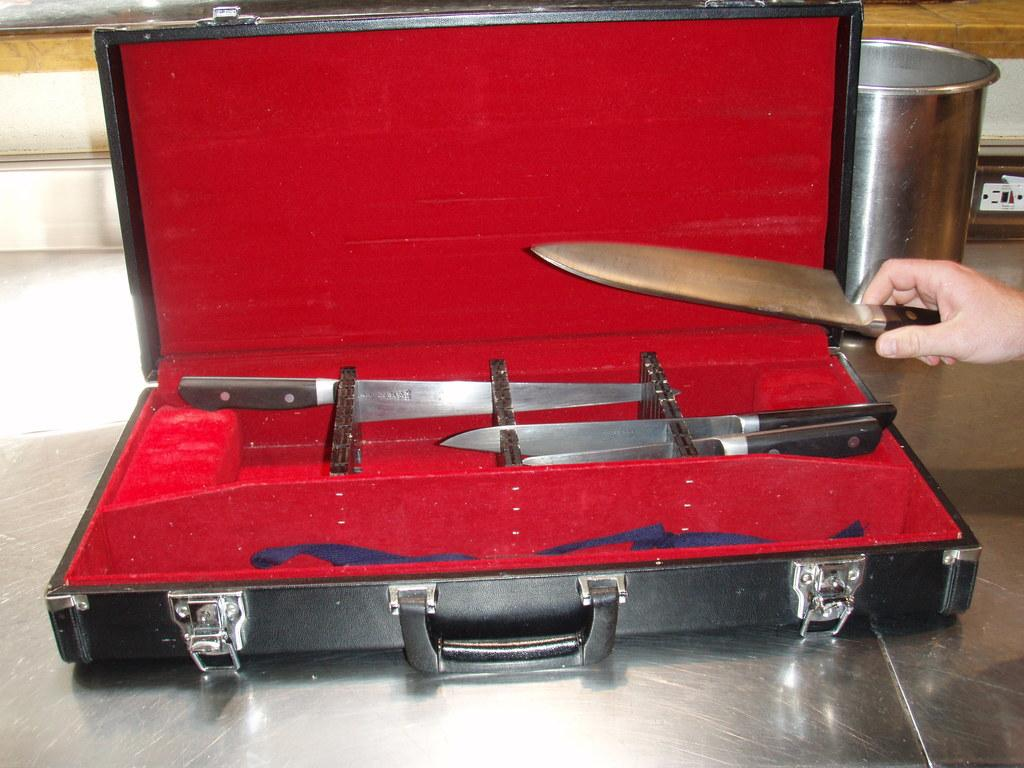What object can be seen in the image that people might use for traveling? There is a suitcase in the image that people might use for traveling. What is placed on top of the suitcase? There is a knife and a red cloth on the suitcase. What can be seen in the background of the image? There is a glass and a hand in the background of the image. What type of sticks can be seen leaning against the wall in the image? There is no wall or sticks present in the image. 